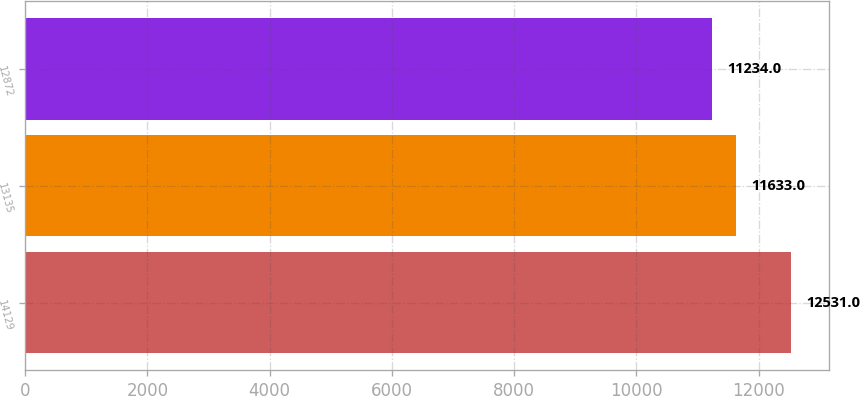Convert chart. <chart><loc_0><loc_0><loc_500><loc_500><bar_chart><fcel>14129<fcel>13135<fcel>12872<nl><fcel>12531<fcel>11633<fcel>11234<nl></chart> 